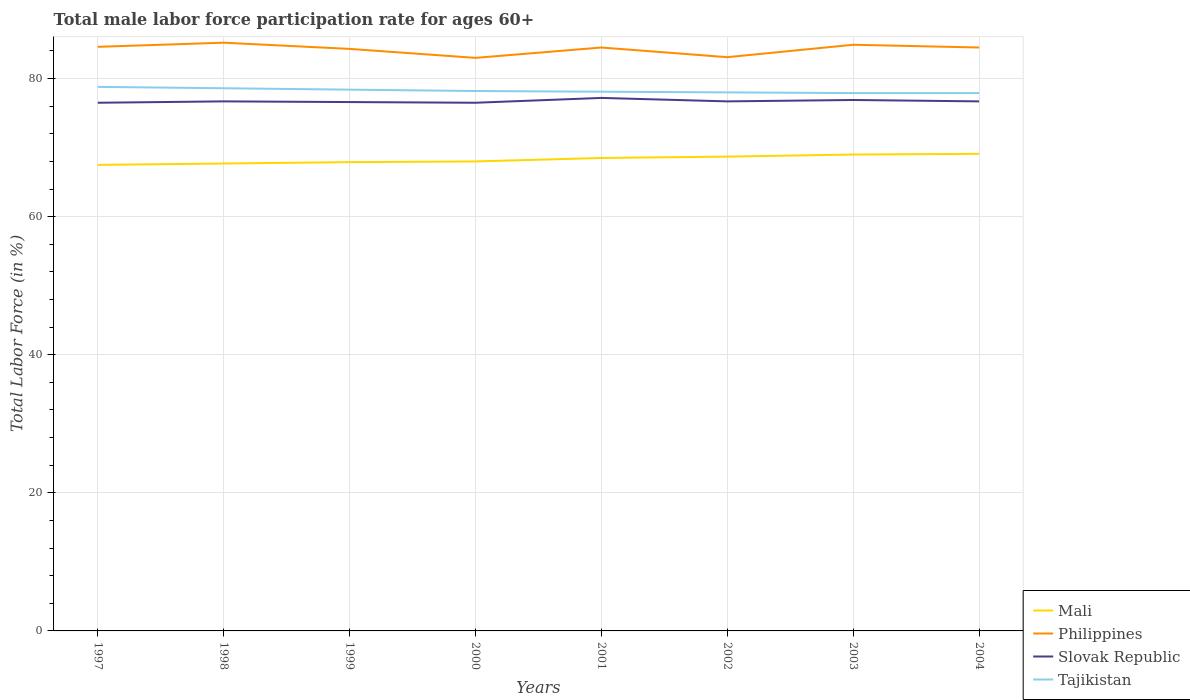Does the line corresponding to Slovak Republic intersect with the line corresponding to Mali?
Provide a short and direct response. No. Across all years, what is the maximum male labor force participation rate in Philippines?
Keep it short and to the point. 83. In which year was the male labor force participation rate in Tajikistan maximum?
Keep it short and to the point. 2003. What is the total male labor force participation rate in Mali in the graph?
Your response must be concise. -1.1. What is the difference between the highest and the second highest male labor force participation rate in Mali?
Provide a succinct answer. 1.6. Is the male labor force participation rate in Mali strictly greater than the male labor force participation rate in Slovak Republic over the years?
Ensure brevity in your answer.  Yes. How many lines are there?
Your answer should be very brief. 4. How many years are there in the graph?
Your answer should be very brief. 8. What is the difference between two consecutive major ticks on the Y-axis?
Your answer should be compact. 20. How are the legend labels stacked?
Make the answer very short. Vertical. What is the title of the graph?
Your response must be concise. Total male labor force participation rate for ages 60+. What is the label or title of the Y-axis?
Provide a short and direct response. Total Labor Force (in %). What is the Total Labor Force (in %) of Mali in 1997?
Offer a very short reply. 67.5. What is the Total Labor Force (in %) in Philippines in 1997?
Your answer should be compact. 84.6. What is the Total Labor Force (in %) in Slovak Republic in 1997?
Your answer should be compact. 76.5. What is the Total Labor Force (in %) in Tajikistan in 1997?
Provide a short and direct response. 78.8. What is the Total Labor Force (in %) in Mali in 1998?
Ensure brevity in your answer.  67.7. What is the Total Labor Force (in %) of Philippines in 1998?
Your answer should be very brief. 85.2. What is the Total Labor Force (in %) in Slovak Republic in 1998?
Ensure brevity in your answer.  76.7. What is the Total Labor Force (in %) of Tajikistan in 1998?
Make the answer very short. 78.6. What is the Total Labor Force (in %) of Mali in 1999?
Make the answer very short. 67.9. What is the Total Labor Force (in %) in Philippines in 1999?
Give a very brief answer. 84.3. What is the Total Labor Force (in %) in Slovak Republic in 1999?
Make the answer very short. 76.6. What is the Total Labor Force (in %) of Tajikistan in 1999?
Your response must be concise. 78.4. What is the Total Labor Force (in %) of Slovak Republic in 2000?
Your response must be concise. 76.5. What is the Total Labor Force (in %) in Tajikistan in 2000?
Provide a succinct answer. 78.2. What is the Total Labor Force (in %) in Mali in 2001?
Your response must be concise. 68.5. What is the Total Labor Force (in %) of Philippines in 2001?
Offer a very short reply. 84.5. What is the Total Labor Force (in %) of Slovak Republic in 2001?
Give a very brief answer. 77.2. What is the Total Labor Force (in %) in Tajikistan in 2001?
Ensure brevity in your answer.  78.1. What is the Total Labor Force (in %) in Mali in 2002?
Your answer should be very brief. 68.7. What is the Total Labor Force (in %) in Philippines in 2002?
Your answer should be compact. 83.1. What is the Total Labor Force (in %) in Slovak Republic in 2002?
Offer a very short reply. 76.7. What is the Total Labor Force (in %) of Philippines in 2003?
Your response must be concise. 84.9. What is the Total Labor Force (in %) in Slovak Republic in 2003?
Your answer should be compact. 76.9. What is the Total Labor Force (in %) of Tajikistan in 2003?
Make the answer very short. 77.9. What is the Total Labor Force (in %) of Mali in 2004?
Keep it short and to the point. 69.1. What is the Total Labor Force (in %) of Philippines in 2004?
Offer a terse response. 84.5. What is the Total Labor Force (in %) in Slovak Republic in 2004?
Offer a terse response. 76.7. What is the Total Labor Force (in %) in Tajikistan in 2004?
Make the answer very short. 77.9. Across all years, what is the maximum Total Labor Force (in %) in Mali?
Your answer should be very brief. 69.1. Across all years, what is the maximum Total Labor Force (in %) of Philippines?
Your answer should be compact. 85.2. Across all years, what is the maximum Total Labor Force (in %) of Slovak Republic?
Your answer should be very brief. 77.2. Across all years, what is the maximum Total Labor Force (in %) in Tajikistan?
Your response must be concise. 78.8. Across all years, what is the minimum Total Labor Force (in %) in Mali?
Give a very brief answer. 67.5. Across all years, what is the minimum Total Labor Force (in %) in Philippines?
Give a very brief answer. 83. Across all years, what is the minimum Total Labor Force (in %) in Slovak Republic?
Your answer should be compact. 76.5. Across all years, what is the minimum Total Labor Force (in %) of Tajikistan?
Ensure brevity in your answer.  77.9. What is the total Total Labor Force (in %) of Mali in the graph?
Your answer should be compact. 546.4. What is the total Total Labor Force (in %) of Philippines in the graph?
Your answer should be very brief. 674.1. What is the total Total Labor Force (in %) in Slovak Republic in the graph?
Ensure brevity in your answer.  613.8. What is the total Total Labor Force (in %) in Tajikistan in the graph?
Give a very brief answer. 625.9. What is the difference between the Total Labor Force (in %) in Mali in 1997 and that in 1998?
Your answer should be compact. -0.2. What is the difference between the Total Labor Force (in %) of Philippines in 1997 and that in 1999?
Give a very brief answer. 0.3. What is the difference between the Total Labor Force (in %) of Slovak Republic in 1997 and that in 1999?
Offer a terse response. -0.1. What is the difference between the Total Labor Force (in %) in Tajikistan in 1997 and that in 1999?
Your answer should be very brief. 0.4. What is the difference between the Total Labor Force (in %) of Mali in 1997 and that in 2000?
Make the answer very short. -0.5. What is the difference between the Total Labor Force (in %) in Philippines in 1997 and that in 2000?
Offer a terse response. 1.6. What is the difference between the Total Labor Force (in %) of Mali in 1997 and that in 2001?
Give a very brief answer. -1. What is the difference between the Total Labor Force (in %) in Philippines in 1997 and that in 2001?
Ensure brevity in your answer.  0.1. What is the difference between the Total Labor Force (in %) of Slovak Republic in 1997 and that in 2001?
Offer a very short reply. -0.7. What is the difference between the Total Labor Force (in %) in Tajikistan in 1997 and that in 2001?
Make the answer very short. 0.7. What is the difference between the Total Labor Force (in %) in Tajikistan in 1997 and that in 2002?
Give a very brief answer. 0.8. What is the difference between the Total Labor Force (in %) of Mali in 1997 and that in 2003?
Provide a succinct answer. -1.5. What is the difference between the Total Labor Force (in %) in Philippines in 1997 and that in 2003?
Offer a terse response. -0.3. What is the difference between the Total Labor Force (in %) of Tajikistan in 1997 and that in 2003?
Offer a very short reply. 0.9. What is the difference between the Total Labor Force (in %) of Philippines in 1997 and that in 2004?
Provide a succinct answer. 0.1. What is the difference between the Total Labor Force (in %) in Philippines in 1998 and that in 2000?
Your response must be concise. 2.2. What is the difference between the Total Labor Force (in %) of Slovak Republic in 1998 and that in 2000?
Offer a very short reply. 0.2. What is the difference between the Total Labor Force (in %) in Philippines in 1998 and that in 2002?
Keep it short and to the point. 2.1. What is the difference between the Total Labor Force (in %) of Tajikistan in 1998 and that in 2002?
Offer a very short reply. 0.6. What is the difference between the Total Labor Force (in %) in Philippines in 1998 and that in 2003?
Provide a succinct answer. 0.3. What is the difference between the Total Labor Force (in %) of Tajikistan in 1998 and that in 2003?
Offer a terse response. 0.7. What is the difference between the Total Labor Force (in %) in Philippines in 1998 and that in 2004?
Offer a terse response. 0.7. What is the difference between the Total Labor Force (in %) of Slovak Republic in 1998 and that in 2004?
Keep it short and to the point. 0. What is the difference between the Total Labor Force (in %) in Mali in 1999 and that in 2000?
Give a very brief answer. -0.1. What is the difference between the Total Labor Force (in %) of Philippines in 1999 and that in 2000?
Your response must be concise. 1.3. What is the difference between the Total Labor Force (in %) in Tajikistan in 1999 and that in 2000?
Ensure brevity in your answer.  0.2. What is the difference between the Total Labor Force (in %) of Tajikistan in 1999 and that in 2001?
Your response must be concise. 0.3. What is the difference between the Total Labor Force (in %) of Mali in 1999 and that in 2002?
Your response must be concise. -0.8. What is the difference between the Total Labor Force (in %) in Slovak Republic in 1999 and that in 2002?
Your answer should be compact. -0.1. What is the difference between the Total Labor Force (in %) of Tajikistan in 1999 and that in 2002?
Offer a very short reply. 0.4. What is the difference between the Total Labor Force (in %) in Slovak Republic in 1999 and that in 2003?
Give a very brief answer. -0.3. What is the difference between the Total Labor Force (in %) in Tajikistan in 1999 and that in 2003?
Offer a very short reply. 0.5. What is the difference between the Total Labor Force (in %) of Mali in 1999 and that in 2004?
Offer a very short reply. -1.2. What is the difference between the Total Labor Force (in %) in Philippines in 1999 and that in 2004?
Your answer should be compact. -0.2. What is the difference between the Total Labor Force (in %) in Tajikistan in 1999 and that in 2004?
Ensure brevity in your answer.  0.5. What is the difference between the Total Labor Force (in %) in Mali in 2000 and that in 2001?
Give a very brief answer. -0.5. What is the difference between the Total Labor Force (in %) in Philippines in 2000 and that in 2001?
Offer a terse response. -1.5. What is the difference between the Total Labor Force (in %) in Slovak Republic in 2000 and that in 2001?
Keep it short and to the point. -0.7. What is the difference between the Total Labor Force (in %) in Tajikistan in 2000 and that in 2001?
Give a very brief answer. 0.1. What is the difference between the Total Labor Force (in %) in Slovak Republic in 2000 and that in 2002?
Make the answer very short. -0.2. What is the difference between the Total Labor Force (in %) of Tajikistan in 2000 and that in 2002?
Your response must be concise. 0.2. What is the difference between the Total Labor Force (in %) in Philippines in 2000 and that in 2003?
Your response must be concise. -1.9. What is the difference between the Total Labor Force (in %) of Slovak Republic in 2000 and that in 2003?
Keep it short and to the point. -0.4. What is the difference between the Total Labor Force (in %) in Philippines in 2000 and that in 2004?
Your response must be concise. -1.5. What is the difference between the Total Labor Force (in %) of Slovak Republic in 2000 and that in 2004?
Your response must be concise. -0.2. What is the difference between the Total Labor Force (in %) of Mali in 2001 and that in 2002?
Provide a short and direct response. -0.2. What is the difference between the Total Labor Force (in %) of Philippines in 2001 and that in 2002?
Make the answer very short. 1.4. What is the difference between the Total Labor Force (in %) of Slovak Republic in 2001 and that in 2002?
Provide a succinct answer. 0.5. What is the difference between the Total Labor Force (in %) of Tajikistan in 2001 and that in 2002?
Give a very brief answer. 0.1. What is the difference between the Total Labor Force (in %) in Slovak Republic in 2001 and that in 2003?
Your answer should be compact. 0.3. What is the difference between the Total Labor Force (in %) in Tajikistan in 2001 and that in 2003?
Your answer should be compact. 0.2. What is the difference between the Total Labor Force (in %) of Tajikistan in 2001 and that in 2004?
Your answer should be compact. 0.2. What is the difference between the Total Labor Force (in %) in Mali in 2002 and that in 2004?
Your response must be concise. -0.4. What is the difference between the Total Labor Force (in %) in Philippines in 2002 and that in 2004?
Your answer should be compact. -1.4. What is the difference between the Total Labor Force (in %) of Mali in 2003 and that in 2004?
Offer a very short reply. -0.1. What is the difference between the Total Labor Force (in %) in Tajikistan in 2003 and that in 2004?
Provide a short and direct response. 0. What is the difference between the Total Labor Force (in %) of Mali in 1997 and the Total Labor Force (in %) of Philippines in 1998?
Offer a very short reply. -17.7. What is the difference between the Total Labor Force (in %) in Mali in 1997 and the Total Labor Force (in %) in Tajikistan in 1998?
Make the answer very short. -11.1. What is the difference between the Total Labor Force (in %) of Philippines in 1997 and the Total Labor Force (in %) of Slovak Republic in 1998?
Keep it short and to the point. 7.9. What is the difference between the Total Labor Force (in %) of Philippines in 1997 and the Total Labor Force (in %) of Tajikistan in 1998?
Your answer should be very brief. 6. What is the difference between the Total Labor Force (in %) of Mali in 1997 and the Total Labor Force (in %) of Philippines in 1999?
Keep it short and to the point. -16.8. What is the difference between the Total Labor Force (in %) in Mali in 1997 and the Total Labor Force (in %) in Philippines in 2000?
Ensure brevity in your answer.  -15.5. What is the difference between the Total Labor Force (in %) in Mali in 1997 and the Total Labor Force (in %) in Tajikistan in 2000?
Ensure brevity in your answer.  -10.7. What is the difference between the Total Labor Force (in %) in Slovak Republic in 1997 and the Total Labor Force (in %) in Tajikistan in 2000?
Ensure brevity in your answer.  -1.7. What is the difference between the Total Labor Force (in %) of Philippines in 1997 and the Total Labor Force (in %) of Slovak Republic in 2001?
Your response must be concise. 7.4. What is the difference between the Total Labor Force (in %) in Mali in 1997 and the Total Labor Force (in %) in Philippines in 2002?
Your answer should be compact. -15.6. What is the difference between the Total Labor Force (in %) in Mali in 1997 and the Total Labor Force (in %) in Slovak Republic in 2002?
Keep it short and to the point. -9.2. What is the difference between the Total Labor Force (in %) of Mali in 1997 and the Total Labor Force (in %) of Tajikistan in 2002?
Ensure brevity in your answer.  -10.5. What is the difference between the Total Labor Force (in %) of Slovak Republic in 1997 and the Total Labor Force (in %) of Tajikistan in 2002?
Provide a succinct answer. -1.5. What is the difference between the Total Labor Force (in %) in Mali in 1997 and the Total Labor Force (in %) in Philippines in 2003?
Keep it short and to the point. -17.4. What is the difference between the Total Labor Force (in %) in Slovak Republic in 1997 and the Total Labor Force (in %) in Tajikistan in 2003?
Give a very brief answer. -1.4. What is the difference between the Total Labor Force (in %) in Mali in 1997 and the Total Labor Force (in %) in Philippines in 2004?
Provide a succinct answer. -17. What is the difference between the Total Labor Force (in %) in Mali in 1997 and the Total Labor Force (in %) in Slovak Republic in 2004?
Make the answer very short. -9.2. What is the difference between the Total Labor Force (in %) in Mali in 1997 and the Total Labor Force (in %) in Tajikistan in 2004?
Offer a terse response. -10.4. What is the difference between the Total Labor Force (in %) in Philippines in 1997 and the Total Labor Force (in %) in Slovak Republic in 2004?
Make the answer very short. 7.9. What is the difference between the Total Labor Force (in %) of Philippines in 1997 and the Total Labor Force (in %) of Tajikistan in 2004?
Your answer should be very brief. 6.7. What is the difference between the Total Labor Force (in %) in Mali in 1998 and the Total Labor Force (in %) in Philippines in 1999?
Your response must be concise. -16.6. What is the difference between the Total Labor Force (in %) of Mali in 1998 and the Total Labor Force (in %) of Slovak Republic in 1999?
Ensure brevity in your answer.  -8.9. What is the difference between the Total Labor Force (in %) in Mali in 1998 and the Total Labor Force (in %) in Tajikistan in 1999?
Ensure brevity in your answer.  -10.7. What is the difference between the Total Labor Force (in %) in Philippines in 1998 and the Total Labor Force (in %) in Tajikistan in 1999?
Make the answer very short. 6.8. What is the difference between the Total Labor Force (in %) of Slovak Republic in 1998 and the Total Labor Force (in %) of Tajikistan in 1999?
Make the answer very short. -1.7. What is the difference between the Total Labor Force (in %) in Mali in 1998 and the Total Labor Force (in %) in Philippines in 2000?
Provide a short and direct response. -15.3. What is the difference between the Total Labor Force (in %) of Mali in 1998 and the Total Labor Force (in %) of Slovak Republic in 2000?
Your answer should be very brief. -8.8. What is the difference between the Total Labor Force (in %) in Mali in 1998 and the Total Labor Force (in %) in Tajikistan in 2000?
Keep it short and to the point. -10.5. What is the difference between the Total Labor Force (in %) of Philippines in 1998 and the Total Labor Force (in %) of Slovak Republic in 2000?
Your answer should be compact. 8.7. What is the difference between the Total Labor Force (in %) in Slovak Republic in 1998 and the Total Labor Force (in %) in Tajikistan in 2000?
Provide a succinct answer. -1.5. What is the difference between the Total Labor Force (in %) in Mali in 1998 and the Total Labor Force (in %) in Philippines in 2001?
Your response must be concise. -16.8. What is the difference between the Total Labor Force (in %) of Philippines in 1998 and the Total Labor Force (in %) of Slovak Republic in 2001?
Give a very brief answer. 8. What is the difference between the Total Labor Force (in %) of Philippines in 1998 and the Total Labor Force (in %) of Tajikistan in 2001?
Keep it short and to the point. 7.1. What is the difference between the Total Labor Force (in %) of Mali in 1998 and the Total Labor Force (in %) of Philippines in 2002?
Provide a succinct answer. -15.4. What is the difference between the Total Labor Force (in %) of Philippines in 1998 and the Total Labor Force (in %) of Slovak Republic in 2002?
Offer a terse response. 8.5. What is the difference between the Total Labor Force (in %) of Mali in 1998 and the Total Labor Force (in %) of Philippines in 2003?
Offer a terse response. -17.2. What is the difference between the Total Labor Force (in %) of Mali in 1998 and the Total Labor Force (in %) of Tajikistan in 2003?
Make the answer very short. -10.2. What is the difference between the Total Labor Force (in %) in Philippines in 1998 and the Total Labor Force (in %) in Tajikistan in 2003?
Keep it short and to the point. 7.3. What is the difference between the Total Labor Force (in %) in Mali in 1998 and the Total Labor Force (in %) in Philippines in 2004?
Your answer should be compact. -16.8. What is the difference between the Total Labor Force (in %) of Mali in 1998 and the Total Labor Force (in %) of Tajikistan in 2004?
Provide a succinct answer. -10.2. What is the difference between the Total Labor Force (in %) of Philippines in 1998 and the Total Labor Force (in %) of Tajikistan in 2004?
Provide a short and direct response. 7.3. What is the difference between the Total Labor Force (in %) in Slovak Republic in 1998 and the Total Labor Force (in %) in Tajikistan in 2004?
Your answer should be very brief. -1.2. What is the difference between the Total Labor Force (in %) in Mali in 1999 and the Total Labor Force (in %) in Philippines in 2000?
Offer a very short reply. -15.1. What is the difference between the Total Labor Force (in %) of Mali in 1999 and the Total Labor Force (in %) of Tajikistan in 2000?
Offer a very short reply. -10.3. What is the difference between the Total Labor Force (in %) of Philippines in 1999 and the Total Labor Force (in %) of Slovak Republic in 2000?
Offer a very short reply. 7.8. What is the difference between the Total Labor Force (in %) in Mali in 1999 and the Total Labor Force (in %) in Philippines in 2001?
Provide a short and direct response. -16.6. What is the difference between the Total Labor Force (in %) of Mali in 1999 and the Total Labor Force (in %) of Slovak Republic in 2001?
Ensure brevity in your answer.  -9.3. What is the difference between the Total Labor Force (in %) of Mali in 1999 and the Total Labor Force (in %) of Tajikistan in 2001?
Your response must be concise. -10.2. What is the difference between the Total Labor Force (in %) in Philippines in 1999 and the Total Labor Force (in %) in Tajikistan in 2001?
Provide a short and direct response. 6.2. What is the difference between the Total Labor Force (in %) of Slovak Republic in 1999 and the Total Labor Force (in %) of Tajikistan in 2001?
Provide a short and direct response. -1.5. What is the difference between the Total Labor Force (in %) of Mali in 1999 and the Total Labor Force (in %) of Philippines in 2002?
Make the answer very short. -15.2. What is the difference between the Total Labor Force (in %) of Mali in 1999 and the Total Labor Force (in %) of Tajikistan in 2002?
Provide a succinct answer. -10.1. What is the difference between the Total Labor Force (in %) in Slovak Republic in 1999 and the Total Labor Force (in %) in Tajikistan in 2002?
Make the answer very short. -1.4. What is the difference between the Total Labor Force (in %) in Mali in 1999 and the Total Labor Force (in %) in Slovak Republic in 2003?
Keep it short and to the point. -9. What is the difference between the Total Labor Force (in %) in Mali in 1999 and the Total Labor Force (in %) in Tajikistan in 2003?
Provide a short and direct response. -10. What is the difference between the Total Labor Force (in %) in Philippines in 1999 and the Total Labor Force (in %) in Tajikistan in 2003?
Make the answer very short. 6.4. What is the difference between the Total Labor Force (in %) of Mali in 1999 and the Total Labor Force (in %) of Philippines in 2004?
Your answer should be very brief. -16.6. What is the difference between the Total Labor Force (in %) in Mali in 1999 and the Total Labor Force (in %) in Slovak Republic in 2004?
Your response must be concise. -8.8. What is the difference between the Total Labor Force (in %) in Philippines in 1999 and the Total Labor Force (in %) in Tajikistan in 2004?
Give a very brief answer. 6.4. What is the difference between the Total Labor Force (in %) of Slovak Republic in 1999 and the Total Labor Force (in %) of Tajikistan in 2004?
Your answer should be very brief. -1.3. What is the difference between the Total Labor Force (in %) of Mali in 2000 and the Total Labor Force (in %) of Philippines in 2001?
Your response must be concise. -16.5. What is the difference between the Total Labor Force (in %) of Slovak Republic in 2000 and the Total Labor Force (in %) of Tajikistan in 2001?
Keep it short and to the point. -1.6. What is the difference between the Total Labor Force (in %) of Mali in 2000 and the Total Labor Force (in %) of Philippines in 2002?
Your answer should be compact. -15.1. What is the difference between the Total Labor Force (in %) in Mali in 2000 and the Total Labor Force (in %) in Slovak Republic in 2002?
Offer a terse response. -8.7. What is the difference between the Total Labor Force (in %) of Mali in 2000 and the Total Labor Force (in %) of Tajikistan in 2002?
Make the answer very short. -10. What is the difference between the Total Labor Force (in %) in Philippines in 2000 and the Total Labor Force (in %) in Tajikistan in 2002?
Keep it short and to the point. 5. What is the difference between the Total Labor Force (in %) in Mali in 2000 and the Total Labor Force (in %) in Philippines in 2003?
Your response must be concise. -16.9. What is the difference between the Total Labor Force (in %) in Mali in 2000 and the Total Labor Force (in %) in Slovak Republic in 2003?
Provide a succinct answer. -8.9. What is the difference between the Total Labor Force (in %) of Philippines in 2000 and the Total Labor Force (in %) of Slovak Republic in 2003?
Keep it short and to the point. 6.1. What is the difference between the Total Labor Force (in %) in Mali in 2000 and the Total Labor Force (in %) in Philippines in 2004?
Offer a very short reply. -16.5. What is the difference between the Total Labor Force (in %) in Mali in 2000 and the Total Labor Force (in %) in Slovak Republic in 2004?
Offer a terse response. -8.7. What is the difference between the Total Labor Force (in %) in Mali in 2000 and the Total Labor Force (in %) in Tajikistan in 2004?
Keep it short and to the point. -9.9. What is the difference between the Total Labor Force (in %) of Philippines in 2000 and the Total Labor Force (in %) of Slovak Republic in 2004?
Your answer should be compact. 6.3. What is the difference between the Total Labor Force (in %) of Slovak Republic in 2000 and the Total Labor Force (in %) of Tajikistan in 2004?
Ensure brevity in your answer.  -1.4. What is the difference between the Total Labor Force (in %) in Mali in 2001 and the Total Labor Force (in %) in Philippines in 2002?
Offer a very short reply. -14.6. What is the difference between the Total Labor Force (in %) of Philippines in 2001 and the Total Labor Force (in %) of Tajikistan in 2002?
Your response must be concise. 6.5. What is the difference between the Total Labor Force (in %) in Mali in 2001 and the Total Labor Force (in %) in Philippines in 2003?
Keep it short and to the point. -16.4. What is the difference between the Total Labor Force (in %) in Mali in 2001 and the Total Labor Force (in %) in Tajikistan in 2003?
Make the answer very short. -9.4. What is the difference between the Total Labor Force (in %) in Philippines in 2001 and the Total Labor Force (in %) in Tajikistan in 2003?
Ensure brevity in your answer.  6.6. What is the difference between the Total Labor Force (in %) of Slovak Republic in 2001 and the Total Labor Force (in %) of Tajikistan in 2003?
Make the answer very short. -0.7. What is the difference between the Total Labor Force (in %) of Mali in 2001 and the Total Labor Force (in %) of Philippines in 2004?
Your answer should be compact. -16. What is the difference between the Total Labor Force (in %) in Mali in 2001 and the Total Labor Force (in %) in Slovak Republic in 2004?
Make the answer very short. -8.2. What is the difference between the Total Labor Force (in %) in Philippines in 2001 and the Total Labor Force (in %) in Slovak Republic in 2004?
Keep it short and to the point. 7.8. What is the difference between the Total Labor Force (in %) of Mali in 2002 and the Total Labor Force (in %) of Philippines in 2003?
Give a very brief answer. -16.2. What is the difference between the Total Labor Force (in %) of Mali in 2002 and the Total Labor Force (in %) of Slovak Republic in 2003?
Your answer should be compact. -8.2. What is the difference between the Total Labor Force (in %) of Philippines in 2002 and the Total Labor Force (in %) of Slovak Republic in 2003?
Your answer should be very brief. 6.2. What is the difference between the Total Labor Force (in %) of Philippines in 2002 and the Total Labor Force (in %) of Tajikistan in 2003?
Provide a short and direct response. 5.2. What is the difference between the Total Labor Force (in %) of Slovak Republic in 2002 and the Total Labor Force (in %) of Tajikistan in 2003?
Provide a succinct answer. -1.2. What is the difference between the Total Labor Force (in %) of Mali in 2002 and the Total Labor Force (in %) of Philippines in 2004?
Provide a short and direct response. -15.8. What is the difference between the Total Labor Force (in %) in Mali in 2002 and the Total Labor Force (in %) in Slovak Republic in 2004?
Your answer should be compact. -8. What is the difference between the Total Labor Force (in %) in Mali in 2002 and the Total Labor Force (in %) in Tajikistan in 2004?
Provide a succinct answer. -9.2. What is the difference between the Total Labor Force (in %) of Philippines in 2002 and the Total Labor Force (in %) of Slovak Republic in 2004?
Your answer should be compact. 6.4. What is the difference between the Total Labor Force (in %) in Mali in 2003 and the Total Labor Force (in %) in Philippines in 2004?
Your answer should be compact. -15.5. What is the difference between the Total Labor Force (in %) of Mali in 2003 and the Total Labor Force (in %) of Slovak Republic in 2004?
Ensure brevity in your answer.  -7.7. What is the difference between the Total Labor Force (in %) in Mali in 2003 and the Total Labor Force (in %) in Tajikistan in 2004?
Keep it short and to the point. -8.9. What is the difference between the Total Labor Force (in %) in Philippines in 2003 and the Total Labor Force (in %) in Tajikistan in 2004?
Ensure brevity in your answer.  7. What is the average Total Labor Force (in %) in Mali per year?
Make the answer very short. 68.3. What is the average Total Labor Force (in %) of Philippines per year?
Give a very brief answer. 84.26. What is the average Total Labor Force (in %) of Slovak Republic per year?
Provide a succinct answer. 76.72. What is the average Total Labor Force (in %) of Tajikistan per year?
Your answer should be compact. 78.24. In the year 1997, what is the difference between the Total Labor Force (in %) of Mali and Total Labor Force (in %) of Philippines?
Ensure brevity in your answer.  -17.1. In the year 1997, what is the difference between the Total Labor Force (in %) of Philippines and Total Labor Force (in %) of Slovak Republic?
Keep it short and to the point. 8.1. In the year 1997, what is the difference between the Total Labor Force (in %) of Philippines and Total Labor Force (in %) of Tajikistan?
Offer a terse response. 5.8. In the year 1998, what is the difference between the Total Labor Force (in %) of Mali and Total Labor Force (in %) of Philippines?
Offer a very short reply. -17.5. In the year 1999, what is the difference between the Total Labor Force (in %) in Mali and Total Labor Force (in %) in Philippines?
Your answer should be very brief. -16.4. In the year 1999, what is the difference between the Total Labor Force (in %) in Mali and Total Labor Force (in %) in Tajikistan?
Offer a terse response. -10.5. In the year 1999, what is the difference between the Total Labor Force (in %) in Philippines and Total Labor Force (in %) in Slovak Republic?
Your answer should be very brief. 7.7. In the year 1999, what is the difference between the Total Labor Force (in %) in Slovak Republic and Total Labor Force (in %) in Tajikistan?
Make the answer very short. -1.8. In the year 2000, what is the difference between the Total Labor Force (in %) of Philippines and Total Labor Force (in %) of Slovak Republic?
Give a very brief answer. 6.5. In the year 2000, what is the difference between the Total Labor Force (in %) of Philippines and Total Labor Force (in %) of Tajikistan?
Ensure brevity in your answer.  4.8. In the year 2001, what is the difference between the Total Labor Force (in %) in Mali and Total Labor Force (in %) in Philippines?
Make the answer very short. -16. In the year 2001, what is the difference between the Total Labor Force (in %) in Mali and Total Labor Force (in %) in Slovak Republic?
Offer a terse response. -8.7. In the year 2001, what is the difference between the Total Labor Force (in %) of Mali and Total Labor Force (in %) of Tajikistan?
Give a very brief answer. -9.6. In the year 2001, what is the difference between the Total Labor Force (in %) of Philippines and Total Labor Force (in %) of Slovak Republic?
Your response must be concise. 7.3. In the year 2001, what is the difference between the Total Labor Force (in %) in Slovak Republic and Total Labor Force (in %) in Tajikistan?
Ensure brevity in your answer.  -0.9. In the year 2002, what is the difference between the Total Labor Force (in %) in Mali and Total Labor Force (in %) in Philippines?
Your answer should be very brief. -14.4. In the year 2002, what is the difference between the Total Labor Force (in %) of Philippines and Total Labor Force (in %) of Tajikistan?
Make the answer very short. 5.1. In the year 2002, what is the difference between the Total Labor Force (in %) in Slovak Republic and Total Labor Force (in %) in Tajikistan?
Keep it short and to the point. -1.3. In the year 2003, what is the difference between the Total Labor Force (in %) in Mali and Total Labor Force (in %) in Philippines?
Give a very brief answer. -15.9. In the year 2003, what is the difference between the Total Labor Force (in %) of Philippines and Total Labor Force (in %) of Tajikistan?
Provide a succinct answer. 7. In the year 2004, what is the difference between the Total Labor Force (in %) of Mali and Total Labor Force (in %) of Philippines?
Your answer should be very brief. -15.4. In the year 2004, what is the difference between the Total Labor Force (in %) of Mali and Total Labor Force (in %) of Tajikistan?
Your response must be concise. -8.8. In the year 2004, what is the difference between the Total Labor Force (in %) in Philippines and Total Labor Force (in %) in Slovak Republic?
Offer a very short reply. 7.8. In the year 2004, what is the difference between the Total Labor Force (in %) in Philippines and Total Labor Force (in %) in Tajikistan?
Keep it short and to the point. 6.6. In the year 2004, what is the difference between the Total Labor Force (in %) in Slovak Republic and Total Labor Force (in %) in Tajikistan?
Make the answer very short. -1.2. What is the ratio of the Total Labor Force (in %) of Mali in 1997 to that in 1998?
Provide a short and direct response. 1. What is the ratio of the Total Labor Force (in %) in Philippines in 1997 to that in 1998?
Give a very brief answer. 0.99. What is the ratio of the Total Labor Force (in %) of Philippines in 1997 to that in 1999?
Your answer should be very brief. 1. What is the ratio of the Total Labor Force (in %) of Tajikistan in 1997 to that in 1999?
Offer a terse response. 1.01. What is the ratio of the Total Labor Force (in %) of Philippines in 1997 to that in 2000?
Your response must be concise. 1.02. What is the ratio of the Total Labor Force (in %) in Slovak Republic in 1997 to that in 2000?
Your answer should be very brief. 1. What is the ratio of the Total Labor Force (in %) of Tajikistan in 1997 to that in 2000?
Give a very brief answer. 1.01. What is the ratio of the Total Labor Force (in %) in Mali in 1997 to that in 2001?
Provide a succinct answer. 0.99. What is the ratio of the Total Labor Force (in %) of Philippines in 1997 to that in 2001?
Offer a very short reply. 1. What is the ratio of the Total Labor Force (in %) of Slovak Republic in 1997 to that in 2001?
Your response must be concise. 0.99. What is the ratio of the Total Labor Force (in %) of Mali in 1997 to that in 2002?
Provide a short and direct response. 0.98. What is the ratio of the Total Labor Force (in %) in Philippines in 1997 to that in 2002?
Your response must be concise. 1.02. What is the ratio of the Total Labor Force (in %) of Tajikistan in 1997 to that in 2002?
Your answer should be very brief. 1.01. What is the ratio of the Total Labor Force (in %) in Mali in 1997 to that in 2003?
Keep it short and to the point. 0.98. What is the ratio of the Total Labor Force (in %) in Tajikistan in 1997 to that in 2003?
Offer a very short reply. 1.01. What is the ratio of the Total Labor Force (in %) of Mali in 1997 to that in 2004?
Keep it short and to the point. 0.98. What is the ratio of the Total Labor Force (in %) in Philippines in 1997 to that in 2004?
Give a very brief answer. 1. What is the ratio of the Total Labor Force (in %) in Tajikistan in 1997 to that in 2004?
Your answer should be very brief. 1.01. What is the ratio of the Total Labor Force (in %) of Mali in 1998 to that in 1999?
Your answer should be very brief. 1. What is the ratio of the Total Labor Force (in %) in Philippines in 1998 to that in 1999?
Ensure brevity in your answer.  1.01. What is the ratio of the Total Labor Force (in %) in Tajikistan in 1998 to that in 1999?
Your response must be concise. 1. What is the ratio of the Total Labor Force (in %) of Mali in 1998 to that in 2000?
Keep it short and to the point. 1. What is the ratio of the Total Labor Force (in %) of Philippines in 1998 to that in 2000?
Provide a succinct answer. 1.03. What is the ratio of the Total Labor Force (in %) of Slovak Republic in 1998 to that in 2000?
Provide a succinct answer. 1. What is the ratio of the Total Labor Force (in %) of Tajikistan in 1998 to that in 2000?
Your response must be concise. 1.01. What is the ratio of the Total Labor Force (in %) in Mali in 1998 to that in 2001?
Keep it short and to the point. 0.99. What is the ratio of the Total Labor Force (in %) in Philippines in 1998 to that in 2001?
Make the answer very short. 1.01. What is the ratio of the Total Labor Force (in %) in Tajikistan in 1998 to that in 2001?
Give a very brief answer. 1.01. What is the ratio of the Total Labor Force (in %) of Mali in 1998 to that in 2002?
Ensure brevity in your answer.  0.99. What is the ratio of the Total Labor Force (in %) in Philippines in 1998 to that in 2002?
Give a very brief answer. 1.03. What is the ratio of the Total Labor Force (in %) in Slovak Republic in 1998 to that in 2002?
Give a very brief answer. 1. What is the ratio of the Total Labor Force (in %) in Tajikistan in 1998 to that in 2002?
Provide a succinct answer. 1.01. What is the ratio of the Total Labor Force (in %) of Mali in 1998 to that in 2003?
Give a very brief answer. 0.98. What is the ratio of the Total Labor Force (in %) of Philippines in 1998 to that in 2003?
Ensure brevity in your answer.  1. What is the ratio of the Total Labor Force (in %) of Tajikistan in 1998 to that in 2003?
Provide a short and direct response. 1.01. What is the ratio of the Total Labor Force (in %) of Mali in 1998 to that in 2004?
Provide a short and direct response. 0.98. What is the ratio of the Total Labor Force (in %) of Philippines in 1998 to that in 2004?
Your answer should be very brief. 1.01. What is the ratio of the Total Labor Force (in %) in Slovak Republic in 1998 to that in 2004?
Make the answer very short. 1. What is the ratio of the Total Labor Force (in %) of Tajikistan in 1998 to that in 2004?
Offer a very short reply. 1.01. What is the ratio of the Total Labor Force (in %) in Philippines in 1999 to that in 2000?
Offer a very short reply. 1.02. What is the ratio of the Total Labor Force (in %) in Slovak Republic in 1999 to that in 2000?
Make the answer very short. 1. What is the ratio of the Total Labor Force (in %) in Mali in 1999 to that in 2001?
Give a very brief answer. 0.99. What is the ratio of the Total Labor Force (in %) of Mali in 1999 to that in 2002?
Offer a terse response. 0.99. What is the ratio of the Total Labor Force (in %) of Philippines in 1999 to that in 2002?
Your answer should be very brief. 1.01. What is the ratio of the Total Labor Force (in %) of Tajikistan in 1999 to that in 2002?
Offer a very short reply. 1.01. What is the ratio of the Total Labor Force (in %) in Mali in 1999 to that in 2003?
Provide a short and direct response. 0.98. What is the ratio of the Total Labor Force (in %) of Slovak Republic in 1999 to that in 2003?
Provide a succinct answer. 1. What is the ratio of the Total Labor Force (in %) in Tajikistan in 1999 to that in 2003?
Offer a terse response. 1.01. What is the ratio of the Total Labor Force (in %) of Mali in 1999 to that in 2004?
Give a very brief answer. 0.98. What is the ratio of the Total Labor Force (in %) in Philippines in 1999 to that in 2004?
Keep it short and to the point. 1. What is the ratio of the Total Labor Force (in %) in Slovak Republic in 1999 to that in 2004?
Your answer should be very brief. 1. What is the ratio of the Total Labor Force (in %) in Tajikistan in 1999 to that in 2004?
Offer a very short reply. 1.01. What is the ratio of the Total Labor Force (in %) in Philippines in 2000 to that in 2001?
Your response must be concise. 0.98. What is the ratio of the Total Labor Force (in %) in Slovak Republic in 2000 to that in 2001?
Your answer should be very brief. 0.99. What is the ratio of the Total Labor Force (in %) in Mali in 2000 to that in 2003?
Your answer should be very brief. 0.99. What is the ratio of the Total Labor Force (in %) in Philippines in 2000 to that in 2003?
Provide a succinct answer. 0.98. What is the ratio of the Total Labor Force (in %) of Slovak Republic in 2000 to that in 2003?
Your response must be concise. 0.99. What is the ratio of the Total Labor Force (in %) of Tajikistan in 2000 to that in 2003?
Offer a terse response. 1. What is the ratio of the Total Labor Force (in %) of Mali in 2000 to that in 2004?
Your answer should be compact. 0.98. What is the ratio of the Total Labor Force (in %) in Philippines in 2000 to that in 2004?
Give a very brief answer. 0.98. What is the ratio of the Total Labor Force (in %) of Tajikistan in 2000 to that in 2004?
Offer a terse response. 1. What is the ratio of the Total Labor Force (in %) of Philippines in 2001 to that in 2002?
Provide a short and direct response. 1.02. What is the ratio of the Total Labor Force (in %) in Tajikistan in 2001 to that in 2002?
Offer a terse response. 1. What is the ratio of the Total Labor Force (in %) in Mali in 2001 to that in 2003?
Your answer should be compact. 0.99. What is the ratio of the Total Labor Force (in %) of Philippines in 2001 to that in 2003?
Provide a succinct answer. 1. What is the ratio of the Total Labor Force (in %) in Slovak Republic in 2001 to that in 2003?
Provide a short and direct response. 1. What is the ratio of the Total Labor Force (in %) in Tajikistan in 2001 to that in 2003?
Offer a terse response. 1. What is the ratio of the Total Labor Force (in %) in Mali in 2001 to that in 2004?
Provide a succinct answer. 0.99. What is the ratio of the Total Labor Force (in %) in Mali in 2002 to that in 2003?
Your answer should be compact. 1. What is the ratio of the Total Labor Force (in %) of Philippines in 2002 to that in 2003?
Provide a succinct answer. 0.98. What is the ratio of the Total Labor Force (in %) in Slovak Republic in 2002 to that in 2003?
Keep it short and to the point. 1. What is the ratio of the Total Labor Force (in %) in Mali in 2002 to that in 2004?
Your response must be concise. 0.99. What is the ratio of the Total Labor Force (in %) of Philippines in 2002 to that in 2004?
Give a very brief answer. 0.98. What is the ratio of the Total Labor Force (in %) in Slovak Republic in 2002 to that in 2004?
Your response must be concise. 1. What is the ratio of the Total Labor Force (in %) in Mali in 2003 to that in 2004?
Provide a short and direct response. 1. What is the ratio of the Total Labor Force (in %) of Philippines in 2003 to that in 2004?
Offer a very short reply. 1. What is the ratio of the Total Labor Force (in %) in Slovak Republic in 2003 to that in 2004?
Provide a succinct answer. 1. What is the ratio of the Total Labor Force (in %) in Tajikistan in 2003 to that in 2004?
Your response must be concise. 1. What is the difference between the highest and the second highest Total Labor Force (in %) of Mali?
Your answer should be compact. 0.1. What is the difference between the highest and the lowest Total Labor Force (in %) in Philippines?
Your answer should be compact. 2.2. What is the difference between the highest and the lowest Total Labor Force (in %) of Tajikistan?
Ensure brevity in your answer.  0.9. 